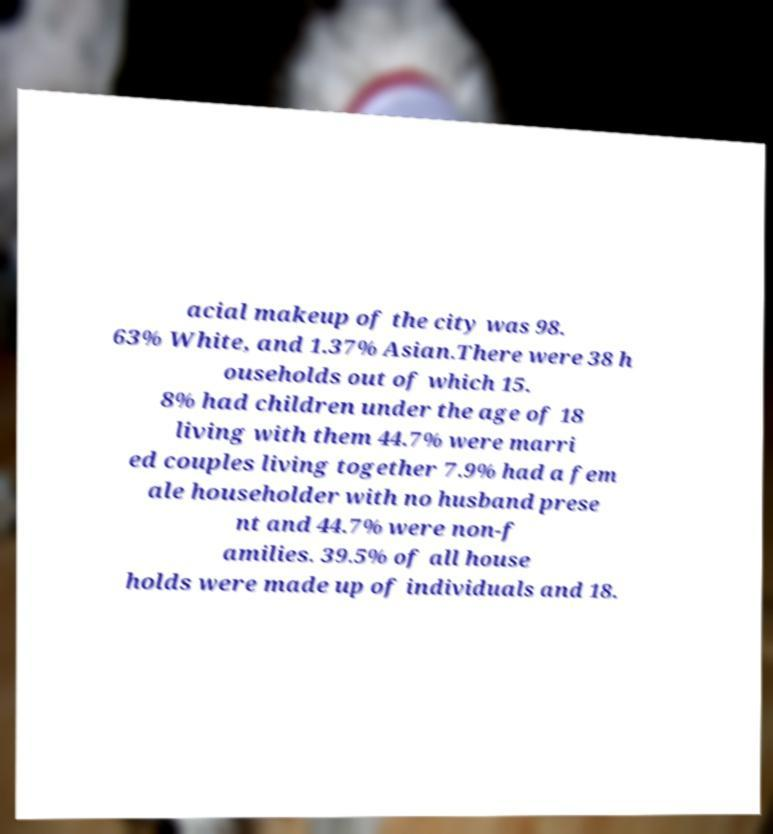Can you read and provide the text displayed in the image?This photo seems to have some interesting text. Can you extract and type it out for me? acial makeup of the city was 98. 63% White, and 1.37% Asian.There were 38 h ouseholds out of which 15. 8% had children under the age of 18 living with them 44.7% were marri ed couples living together 7.9% had a fem ale householder with no husband prese nt and 44.7% were non-f amilies. 39.5% of all house holds were made up of individuals and 18. 